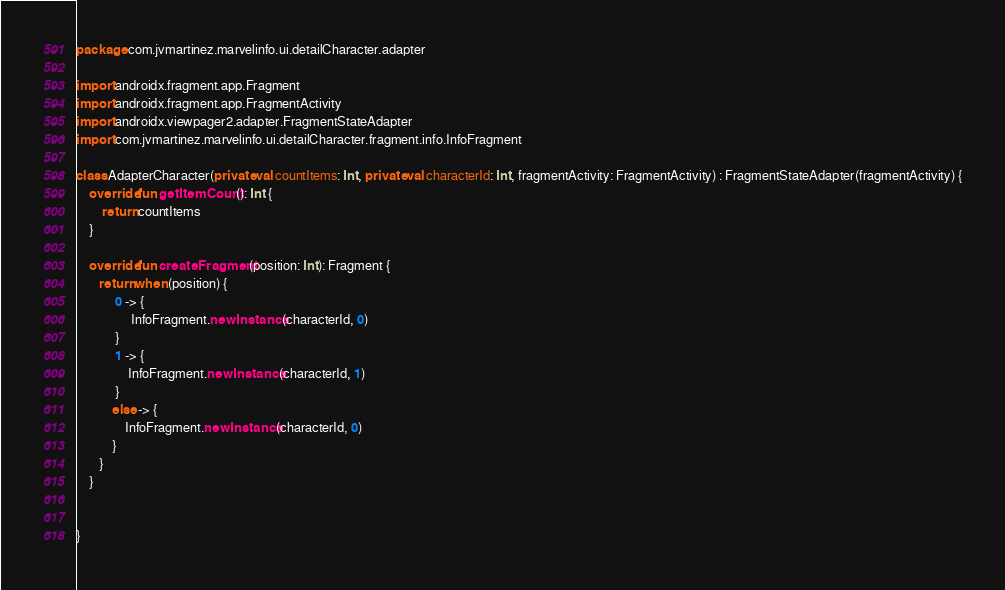Convert code to text. <code><loc_0><loc_0><loc_500><loc_500><_Kotlin_>package com.jvmartinez.marvelinfo.ui.detailCharacter.adapter

import androidx.fragment.app.Fragment
import androidx.fragment.app.FragmentActivity
import androidx.viewpager2.adapter.FragmentStateAdapter
import com.jvmartinez.marvelinfo.ui.detailCharacter.fragment.info.InfoFragment

class AdapterCharacter(private val countItems: Int, private val characterId: Int, fragmentActivity: FragmentActivity) : FragmentStateAdapter(fragmentActivity) {
    override fun getItemCount(): Int {
        return countItems
    }

    override fun createFragment(position: Int): Fragment {
       return when (position) {
            0 -> {
                 InfoFragment.newInstance(characterId, 0)
            }
            1 -> {
                InfoFragment.newInstance(characterId, 1)
            }
           else -> {
               InfoFragment.newInstance(characterId, 0)
           }
       }
    }


}</code> 